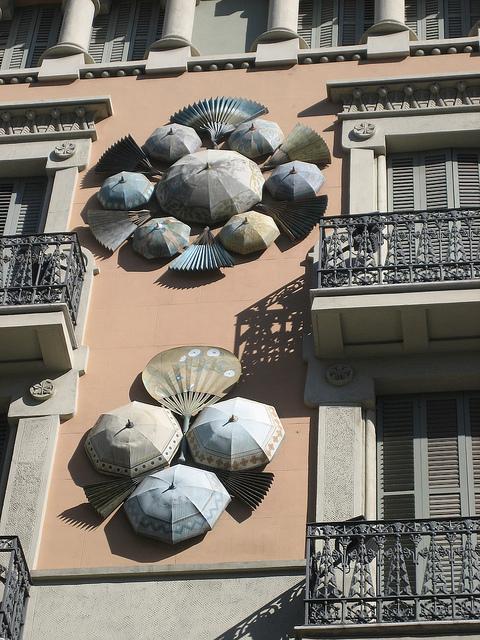Are the umbrellas organized in a particular formation?
Quick response, please. Yes. Are those umbrellas?
Quick response, please. Yes. What surrounds each balcony?
Answer briefly. Umbrellas. 